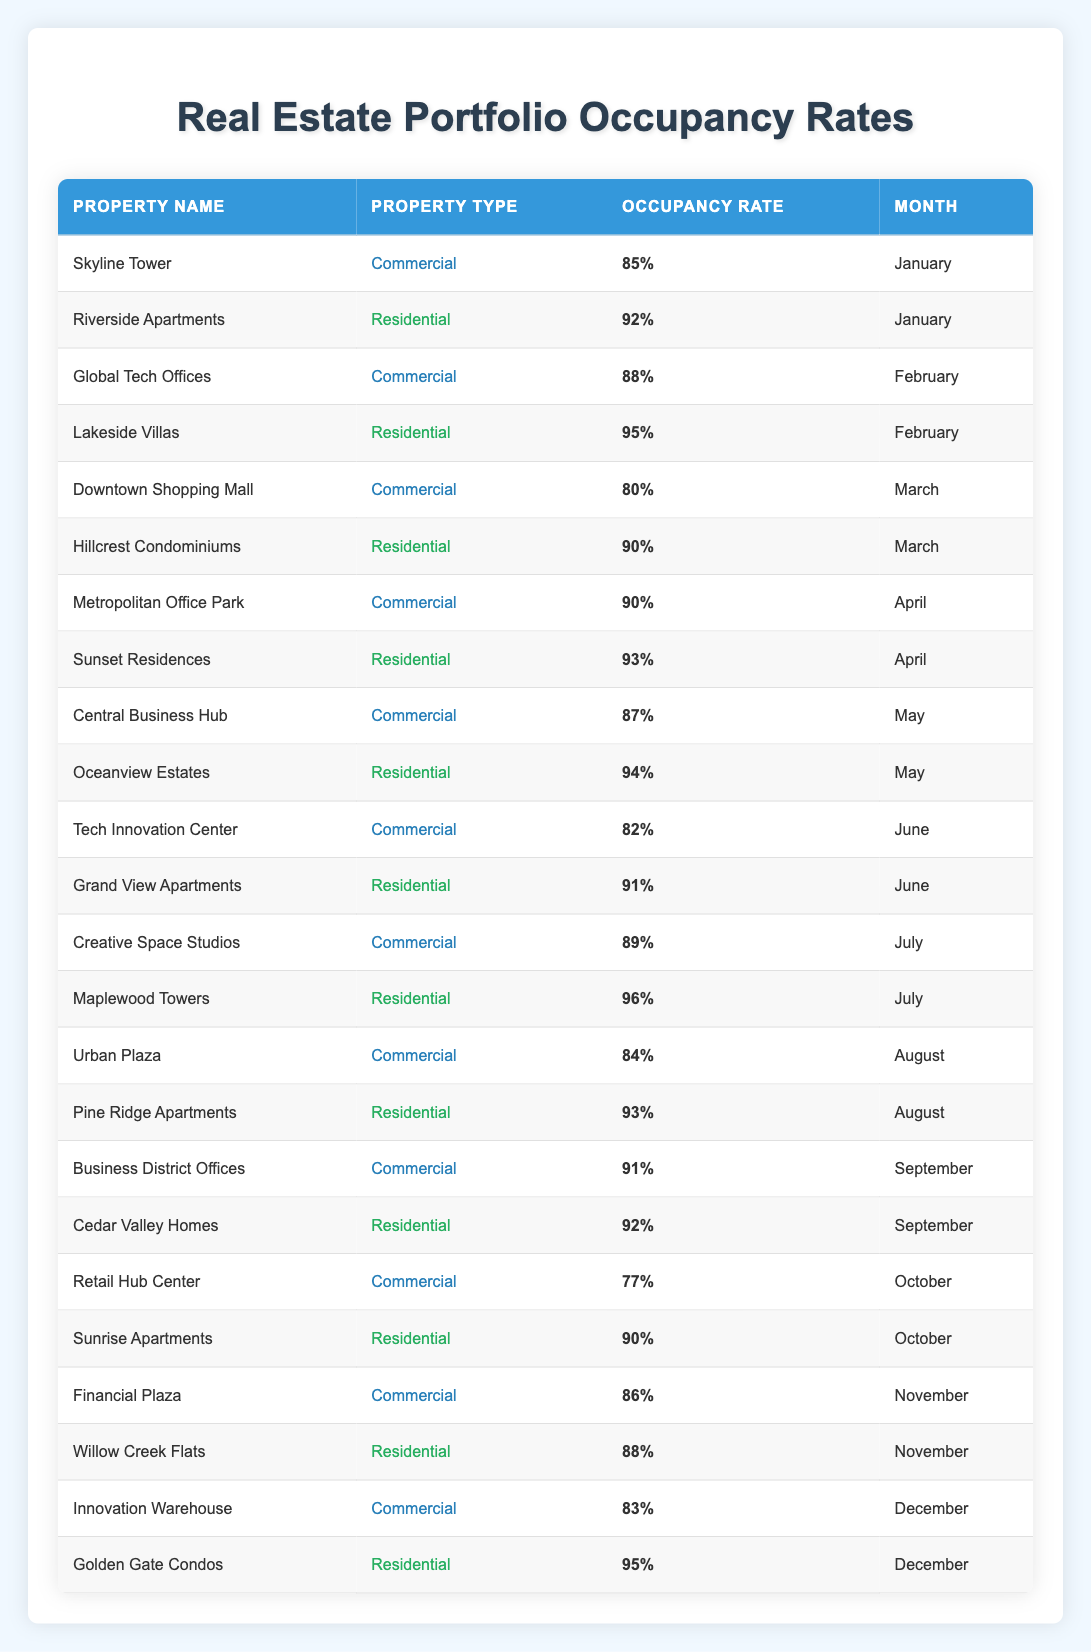What is the occupancy rate of Skyline Tower? The table shows an entry for Skyline Tower, which has an occupancy rate of 85% in January.
Answer: 85% Which property type has a higher average occupancy rate, commercial or residential? First, calculate the average occupancy rate for commercial properties: (85 + 88 + 80 + 90 + 87 + 82 + 89 + 84 + 91 + 77 + 86 + 83)/12 = 83.25%. Next, calculate for residential properties: (92 + 95 + 90 + 93 + 94 + 91 + 96 + 93 + 92 + 90 + 88 + 95)/12 = 91.25%. Since 91.25% > 83.25%, residential has the higher average.
Answer: Residential Is the occupancy rate of the Business District Offices higher than 85%? The table lists the occupancy rate for Business District Offices as 91%, which is indeed higher than 85%.
Answer: Yes Which month had the highest recorded occupancy rate for commercial properties? Reviewing the data for commercial properties, the highest occupancy recorded is for Metropolitan Office Park at 90% in April.
Answer: April How many residential properties have an occupancy rate above 92%? Examining the residential properties, the following have occupancy rates above 92%: Lakeside Villas (95), Maplewood Towers (96), and Golden Gate Condos (95). Thus, there are three such properties.
Answer: 3 Was there any month where a commercial property had an occupancy rate lower than 80%? Yes, the Retail Hub Center in October had an occupancy rate of 77%, which is lower than 80%.
Answer: Yes What is the difference between the highest and lowest occupancy rates among residential properties? The highest residential occupancy rate is for Maplewood Towers at 96%, and the lowest is for Willow Creek Flats at 88%. The difference is 96 - 88 = 8%.
Answer: 8% In which month did the highest occupancy rate for residential properties occur, and what was that rate? The highest rate for residential properties is 96% in July, as noted for Maplewood Towers.
Answer: July, 96% Which commercial property had the lowest occupancy rate, and how much was it? The table shows that the Retail Hub Center had the lowest occupancy rate at 77% in October.
Answer: Retail Hub Center, 77% 